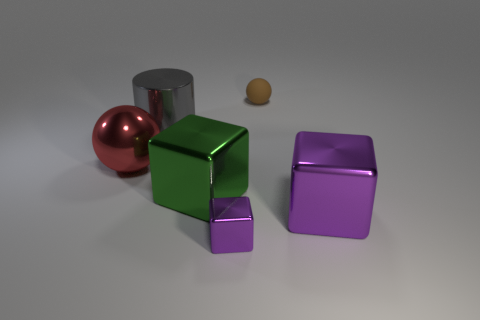There is a cube that is on the right side of the rubber object; what material is it? The cube that's positioned to the right of the rubber object appears to have a reflective surface with sharp edges, which indicates that it is likely made of metal, giving it a sleek and solid appearance. 